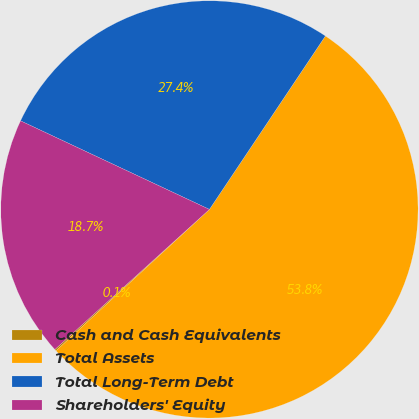Convert chart. <chart><loc_0><loc_0><loc_500><loc_500><pie_chart><fcel>Cash and Cash Equivalents<fcel>Total Assets<fcel>Total Long-Term Debt<fcel>Shareholders' Equity<nl><fcel>0.13%<fcel>53.77%<fcel>27.4%<fcel>18.7%<nl></chart> 